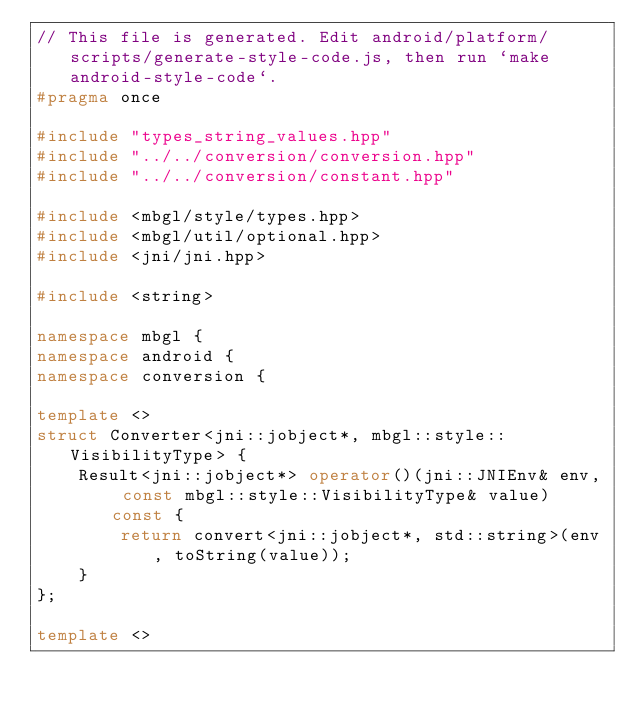Convert code to text. <code><loc_0><loc_0><loc_500><loc_500><_C++_>// This file is generated. Edit android/platform/scripts/generate-style-code.js, then run `make android-style-code`.
#pragma once

#include "types_string_values.hpp"
#include "../../conversion/conversion.hpp"
#include "../../conversion/constant.hpp"

#include <mbgl/style/types.hpp>
#include <mbgl/util/optional.hpp>
#include <jni/jni.hpp>

#include <string>

namespace mbgl {
namespace android {
namespace conversion {

template <>
struct Converter<jni::jobject*, mbgl::style::VisibilityType> {
    Result<jni::jobject*> operator()(jni::JNIEnv& env, const mbgl::style::VisibilityType& value) const {
        return convert<jni::jobject*, std::string>(env, toString(value));
    }
};

template <></code> 